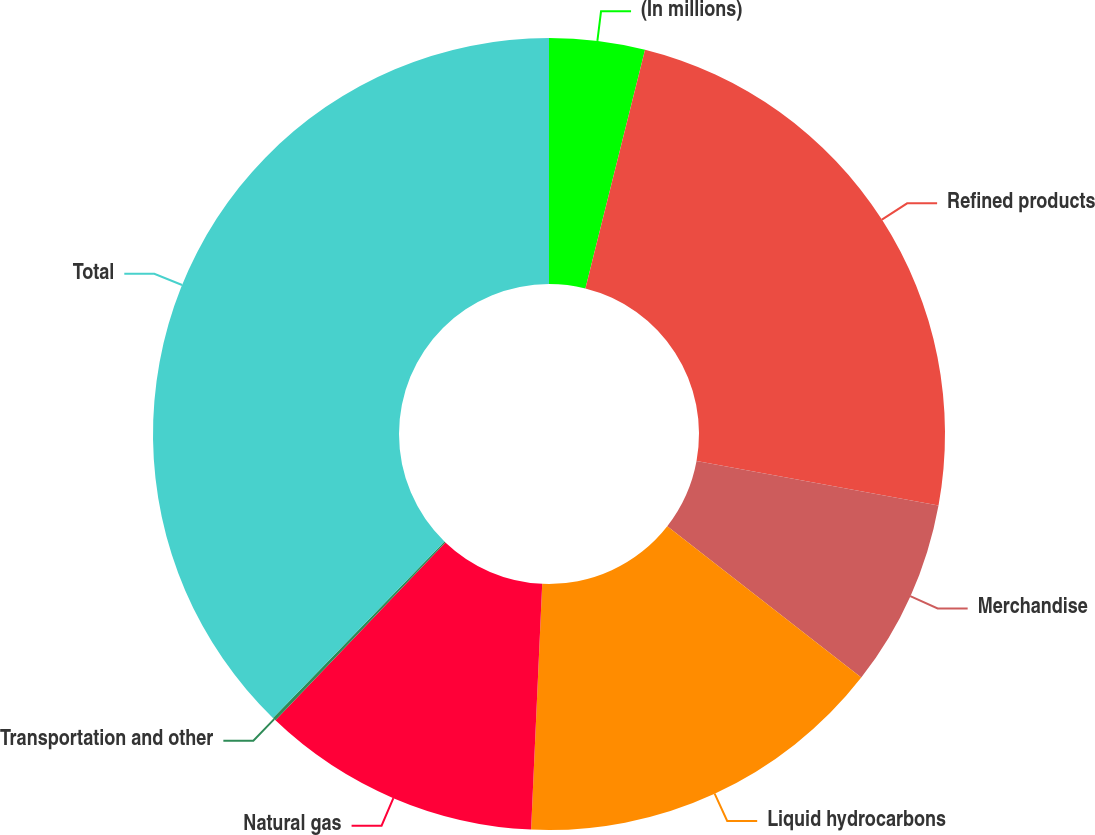Convert chart. <chart><loc_0><loc_0><loc_500><loc_500><pie_chart><fcel>(In millions)<fcel>Refined products<fcel>Merchandise<fcel>Liquid hydrocarbons<fcel>Natural gas<fcel>Transportation and other<fcel>Total<nl><fcel>3.9%<fcel>23.99%<fcel>7.66%<fcel>15.18%<fcel>11.42%<fcel>0.14%<fcel>37.73%<nl></chart> 